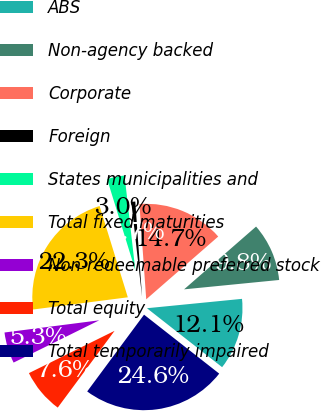Convert chart to OTSL. <chart><loc_0><loc_0><loc_500><loc_500><pie_chart><fcel>ABS<fcel>Non-agency backed<fcel>Corporate<fcel>Foreign<fcel>States municipalities and<fcel>Total fixed maturities<fcel>Non-redeemable preferred stock<fcel>Total equity<fcel>Total temporarily impaired<nl><fcel>12.15%<fcel>9.85%<fcel>14.72%<fcel>0.67%<fcel>2.97%<fcel>22.27%<fcel>5.26%<fcel>7.56%<fcel>24.56%<nl></chart> 